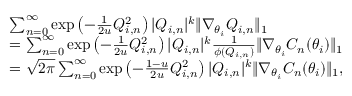Convert formula to latex. <formula><loc_0><loc_0><loc_500><loc_500>\begin{array} { r l } & { \sum _ { n = 0 } ^ { \infty } \exp \left ( - \frac { 1 } { 2 u } Q _ { i , n } ^ { 2 } \right ) | Q _ { i , n } | ^ { k } \| \nabla _ { \theta _ { i } } Q _ { i , n } \| _ { 1 } } \\ & { = \sum _ { n = 0 } ^ { \infty } \exp \left ( - \frac { 1 } { 2 u } Q _ { i , n } ^ { 2 } \right ) | Q _ { i , n } | ^ { k } \frac { 1 } { \phi ( Q _ { i , n } ) } \| \nabla _ { \theta _ { i } } C _ { n } ( \theta _ { i } ) \| _ { 1 } } \\ & { = \sqrt { 2 \pi } \sum _ { n = 0 } ^ { \infty } \exp \left ( - \frac { 1 - u } { 2 u } Q _ { i , n } ^ { 2 } \right ) | Q _ { i , n } | ^ { k } \| \nabla _ { \theta _ { i } } C _ { n } ( \theta _ { i } ) \| _ { 1 } , } \end{array}</formula> 